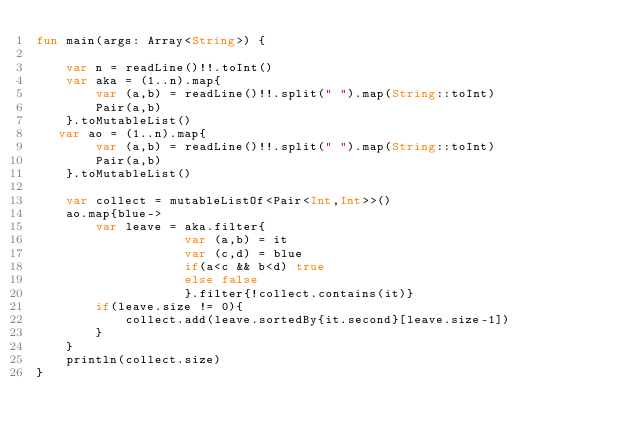<code> <loc_0><loc_0><loc_500><loc_500><_Kotlin_>fun main(args: Array<String>) {
    
    var n = readLine()!!.toInt()
    var aka = (1..n).map{
        var (a,b) = readLine()!!.split(" ").map(String::toInt)
        Pair(a,b)
    }.toMutableList()
   var ao = (1..n).map{
        var (a,b) = readLine()!!.split(" ").map(String::toInt)
        Pair(a,b)
    }.toMutableList()

    var collect = mutableListOf<Pair<Int,Int>>()
    ao.map{blue->
        var leave = aka.filter{
                    var (a,b) = it
                    var (c,d) = blue
                    if(a<c && b<d) true
                    else false
                    }.filter{!collect.contains(it)}
        if(leave.size != 0){
            collect.add(leave.sortedBy{it.second}[leave.size-1])
        }
    }
    println(collect.size)
}</code> 